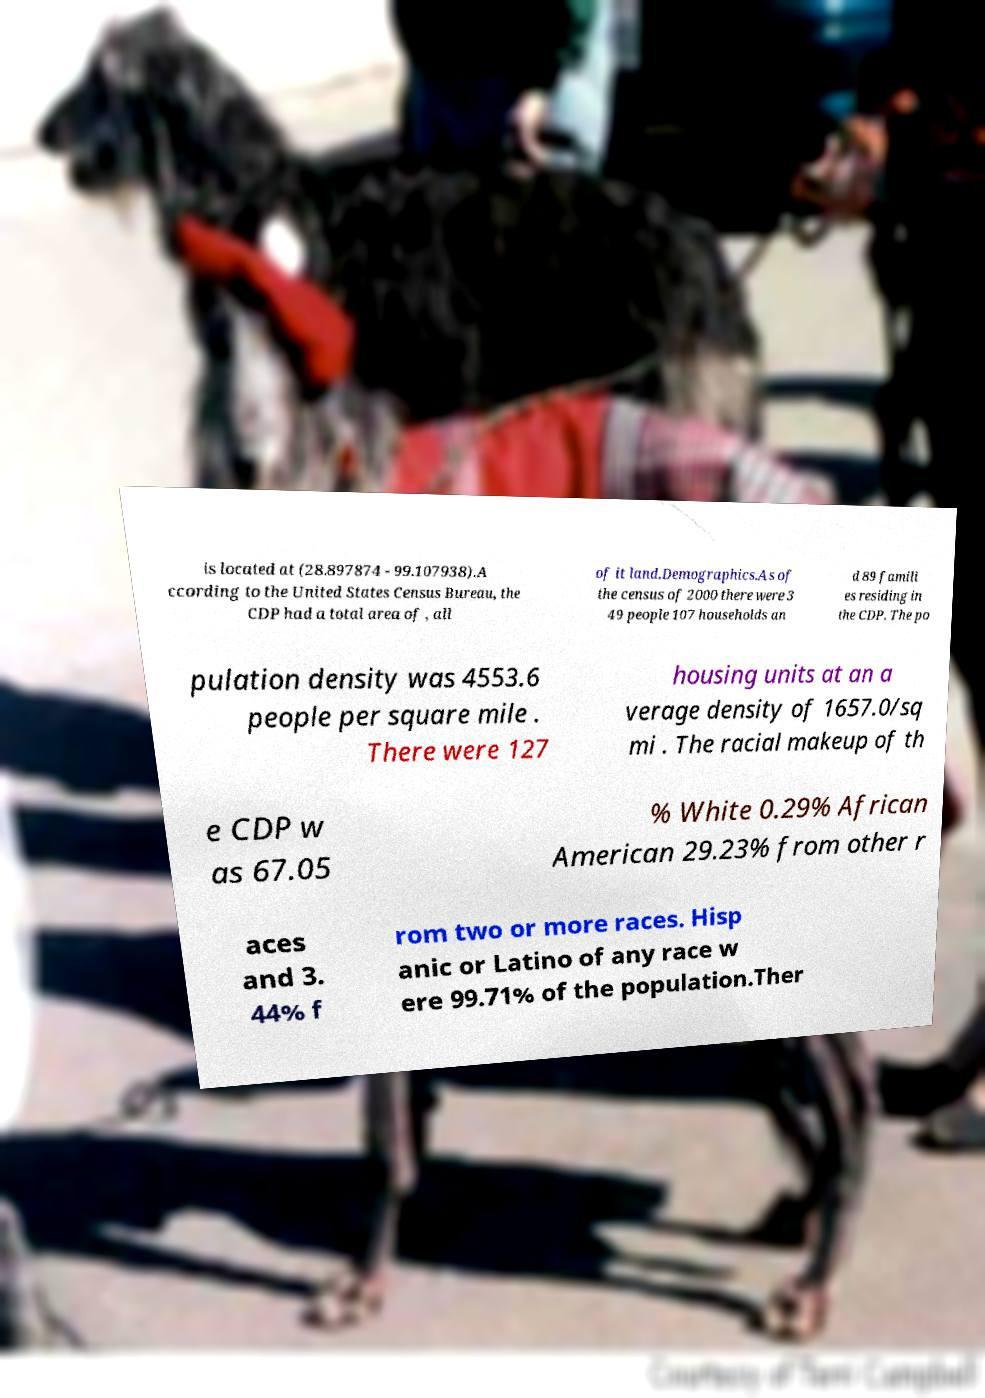Please identify and transcribe the text found in this image. is located at (28.897874 - 99.107938).A ccording to the United States Census Bureau, the CDP had a total area of , all of it land.Demographics.As of the census of 2000 there were 3 49 people 107 households an d 89 famili es residing in the CDP. The po pulation density was 4553.6 people per square mile . There were 127 housing units at an a verage density of 1657.0/sq mi . The racial makeup of th e CDP w as 67.05 % White 0.29% African American 29.23% from other r aces and 3. 44% f rom two or more races. Hisp anic or Latino of any race w ere 99.71% of the population.Ther 